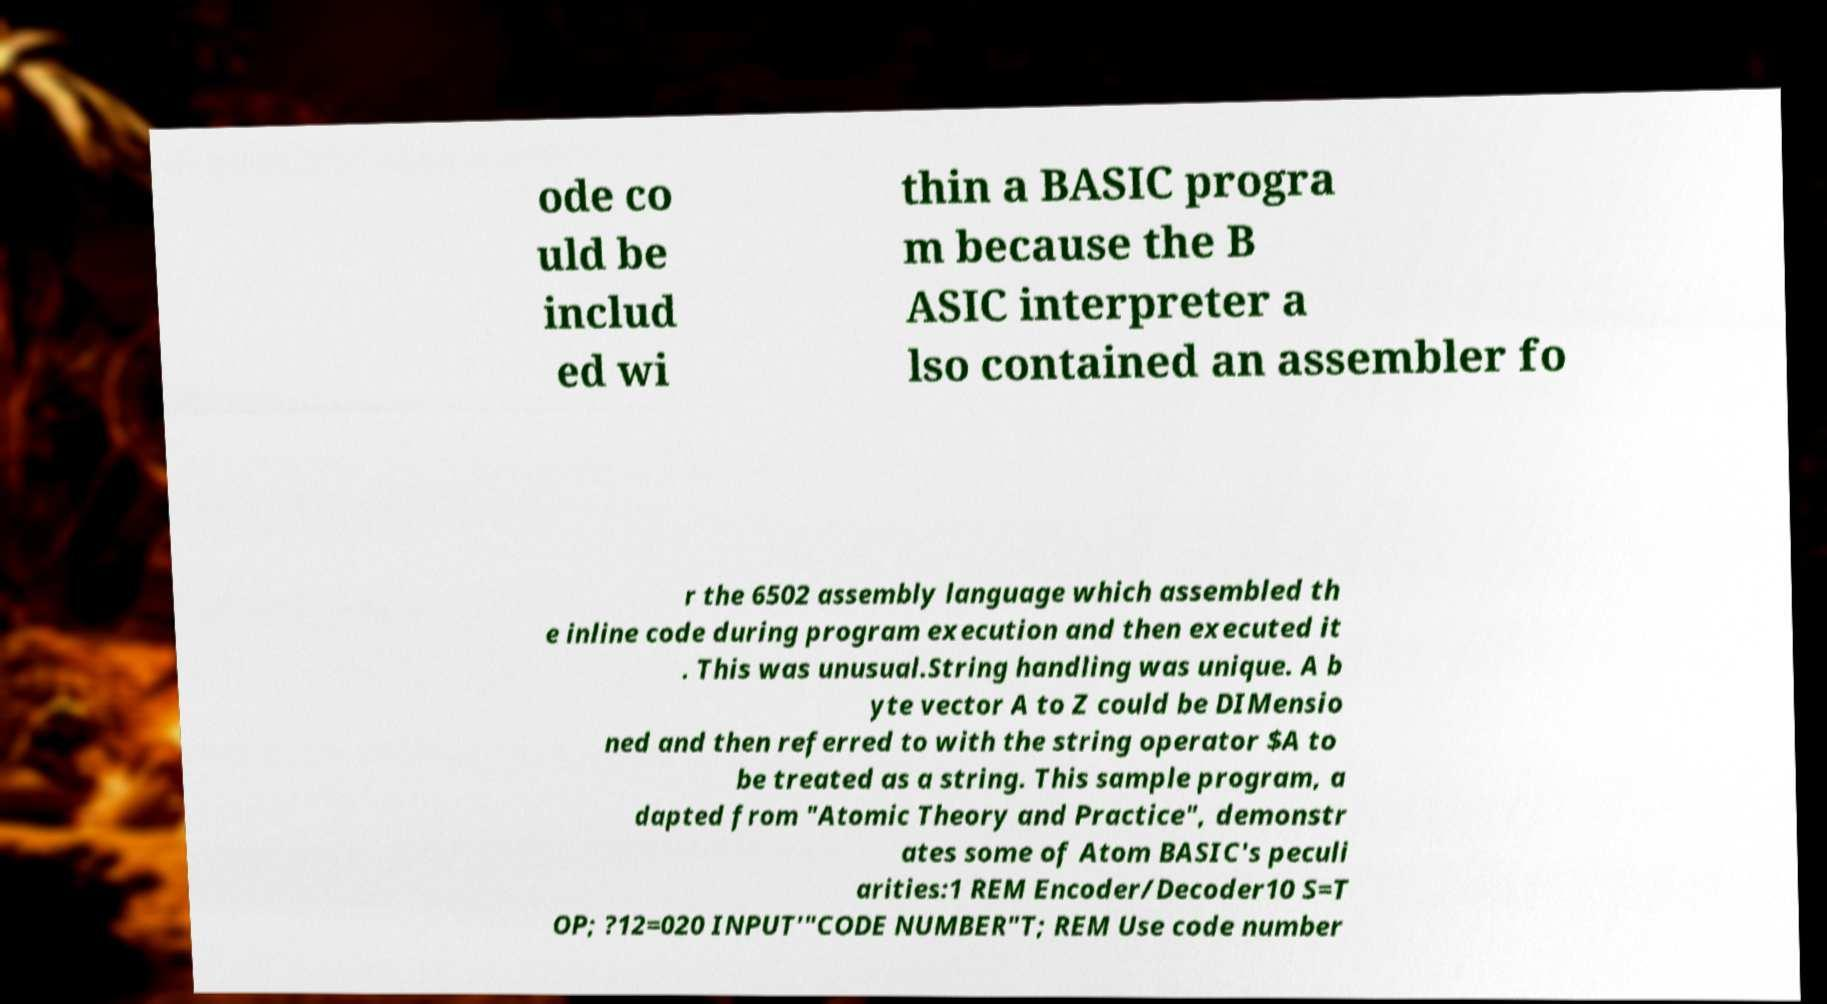I need the written content from this picture converted into text. Can you do that? ode co uld be includ ed wi thin a BASIC progra m because the B ASIC interpreter a lso contained an assembler fo r the 6502 assembly language which assembled th e inline code during program execution and then executed it . This was unusual.String handling was unique. A b yte vector A to Z could be DIMensio ned and then referred to with the string operator $A to be treated as a string. This sample program, a dapted from "Atomic Theory and Practice", demonstr ates some of Atom BASIC's peculi arities:1 REM Encoder/Decoder10 S=T OP; ?12=020 INPUT'"CODE NUMBER"T; REM Use code number 